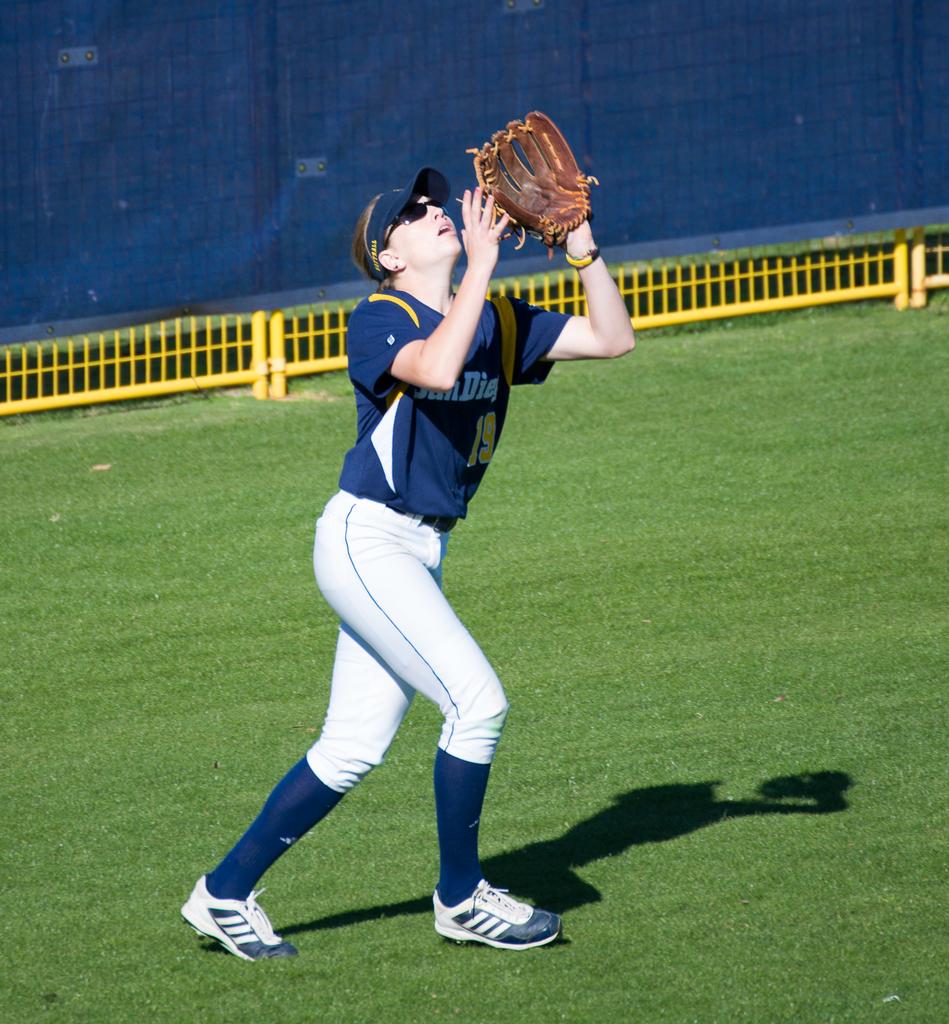Is that player 19?
Your answer should be very brief. Yes. What capital letter can be made out on the shirt?
Provide a short and direct response. D. 